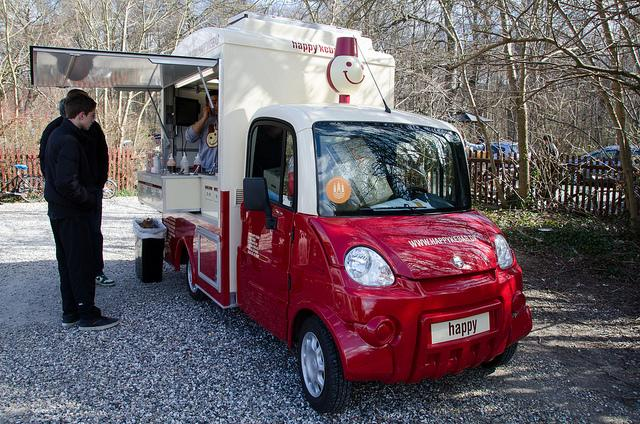Where could someone put their garbage?

Choices:
A) cab
B) kitchen
C) rubbish bin
D) forest ground rubbish bin 